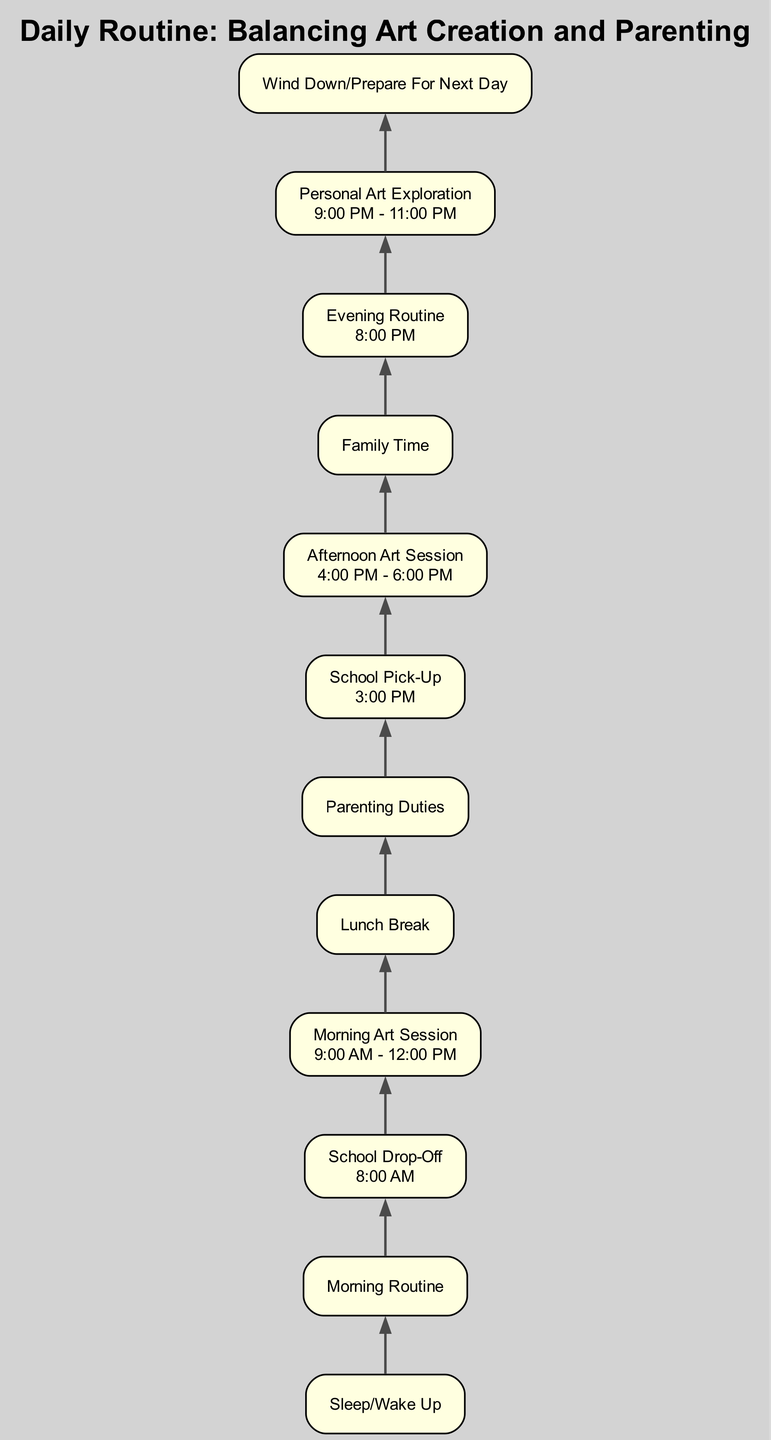What is the first node in the diagram? The first node in the diagram represents the initial action in the daily routine, which is "Sleep/Wake Up." It is located at the bottom of the flow chart, denoting the start of the sequence.
Answer: Sleep/Wake Up How many nodes are present in the diagram? By counting each distinct activity or step in the diagram, we find there are 12 nodes representing various actions throughout the daily routine.
Answer: 12 What time is the "School Drop-Off"? The "School Drop-Off" node specifies a clear time of "8:00 AM." This time is provided directly in the label associated with that node.
Answer: 8:00 AM What is the relationship between "School Pick-Up" and "Afternoon Art Session"? The diagram shows that "School Pick-Up" is followed directly by "Afternoon Art Session." This relationship indicates the transition between picking up the children and engaging in art creation.
Answer: Afternoon Art Session follows School Pick-Up Which activity involves personal downtime? The "Lunch Break" node indicates a period dedicated to taking a break for lunch and personal downtime. It is clearly labeled in the diagram.
Answer: Lunch Break During which time is "Personal Art Exploration" scheduled? The "Personal Art Exploration" node specifies that it takes place from "9:00 PM to 11:00 PM." This timeframe is stated directly in the label of the respective node.
Answer: 9:00 PM - 11:00 PM What precedes "Family Time"? The diagram shows that "Evening Routine" directly precedes "Family Time," indicating it is a necessary step that comes before spending quality time with family.
Answer: Evening Routine What is the last node in the diagram? The last node in the diagram is "Wind Down/Prepare For Next Day," which is located at the top, indicating it is the final activity of the daily routine.
Answer: Wind Down/Prepare For Next Day What happens after "Morning Art Session"? Following "Morning Art Session," the next step in the flow is "Lunch Break," which indicates a transition from art creation to a period of rest and nourishment.
Answer: Lunch Break 